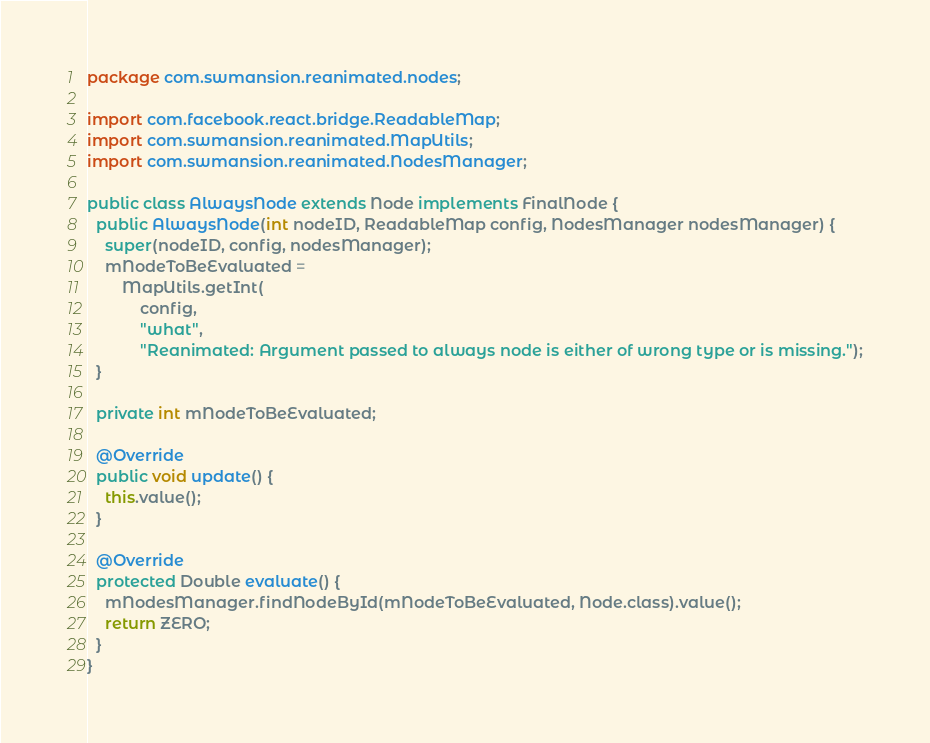<code> <loc_0><loc_0><loc_500><loc_500><_Java_>package com.swmansion.reanimated.nodes;

import com.facebook.react.bridge.ReadableMap;
import com.swmansion.reanimated.MapUtils;
import com.swmansion.reanimated.NodesManager;

public class AlwaysNode extends Node implements FinalNode {
  public AlwaysNode(int nodeID, ReadableMap config, NodesManager nodesManager) {
    super(nodeID, config, nodesManager);
    mNodeToBeEvaluated =
        MapUtils.getInt(
            config,
            "what",
            "Reanimated: Argument passed to always node is either of wrong type or is missing.");
  }

  private int mNodeToBeEvaluated;

  @Override
  public void update() {
    this.value();
  }

  @Override
  protected Double evaluate() {
    mNodesManager.findNodeById(mNodeToBeEvaluated, Node.class).value();
    return ZERO;
  }
}
</code> 